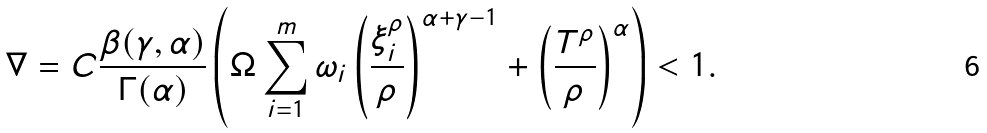Convert formula to latex. <formula><loc_0><loc_0><loc_500><loc_500>\nabla = C \frac { \beta ( \gamma , \alpha ) } { \Gamma ( \alpha ) } \left ( \Omega \sum _ { i = 1 } ^ { m } \omega _ { i } \left ( \frac { \xi _ { i } ^ { \rho } } { \rho } \right ) ^ { \alpha + \gamma - 1 } + \left ( \frac { T ^ { \rho } } { \rho } \right ) ^ { \alpha } \right ) < 1 .</formula> 